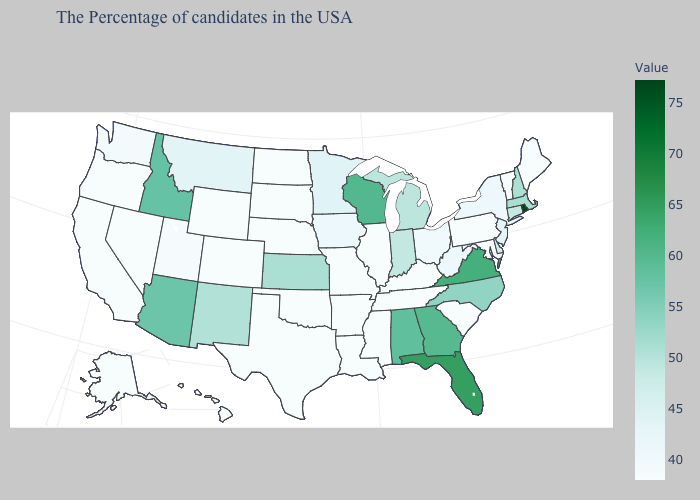Which states hav the highest value in the Northeast?
Be succinct. Rhode Island. Which states hav the highest value in the Northeast?
Keep it brief. Rhode Island. Which states have the lowest value in the Northeast?
Write a very short answer. Maine, Vermont, Pennsylvania. Among the states that border Pennsylvania , which have the lowest value?
Be succinct. Maryland. Which states hav the highest value in the South?
Short answer required. Florida. Does Utah have the lowest value in the West?
Give a very brief answer. No. Does Pennsylvania have the lowest value in the Northeast?
Quick response, please. Yes. 